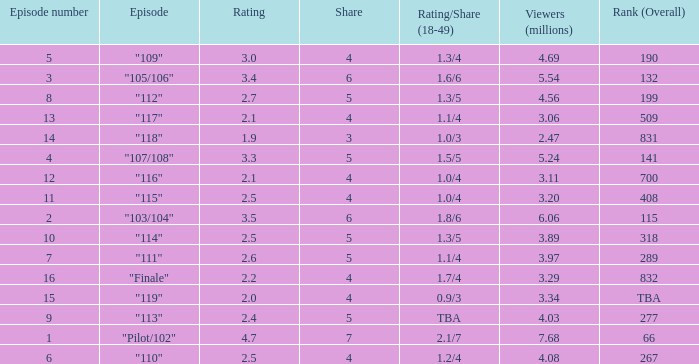WHAT IS THE NUMBER OF VIEWERS WITH EPISODE LARGER THAN 10, RATING SMALLER THAN 2? 2.47. 